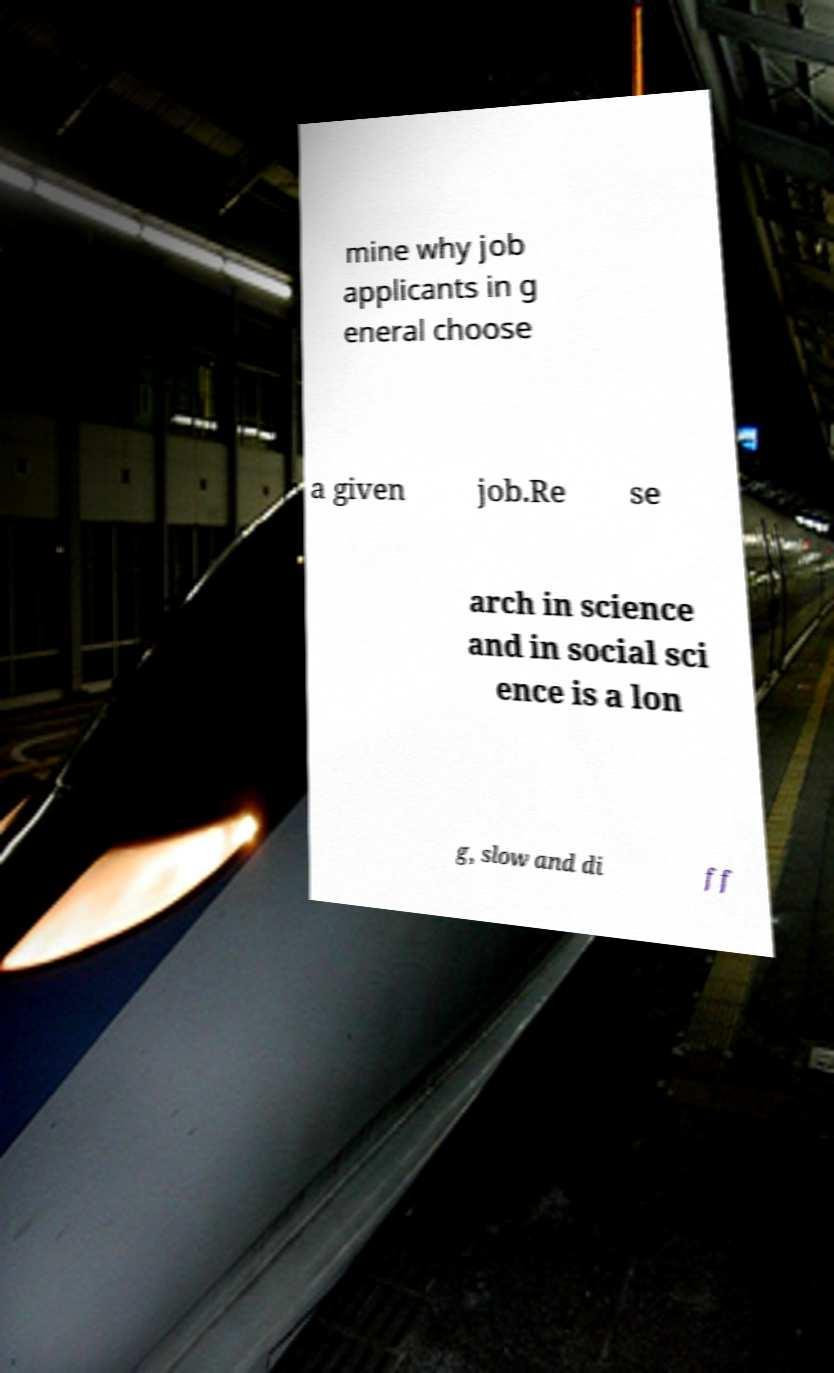What messages or text are displayed in this image? I need them in a readable, typed format. mine why job applicants in g eneral choose a given job.Re se arch in science and in social sci ence is a lon g, slow and di ff 